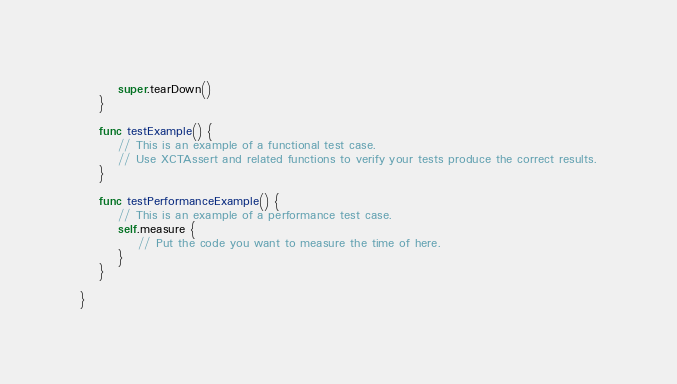<code> <loc_0><loc_0><loc_500><loc_500><_Swift_>        super.tearDown()
    }
    
    func testExample() {
        // This is an example of a functional test case.
        // Use XCTAssert and related functions to verify your tests produce the correct results.
    }
    
    func testPerformanceExample() {
        // This is an example of a performance test case.
        self.measure {
            // Put the code you want to measure the time of here.
        }
    }
    
}
</code> 